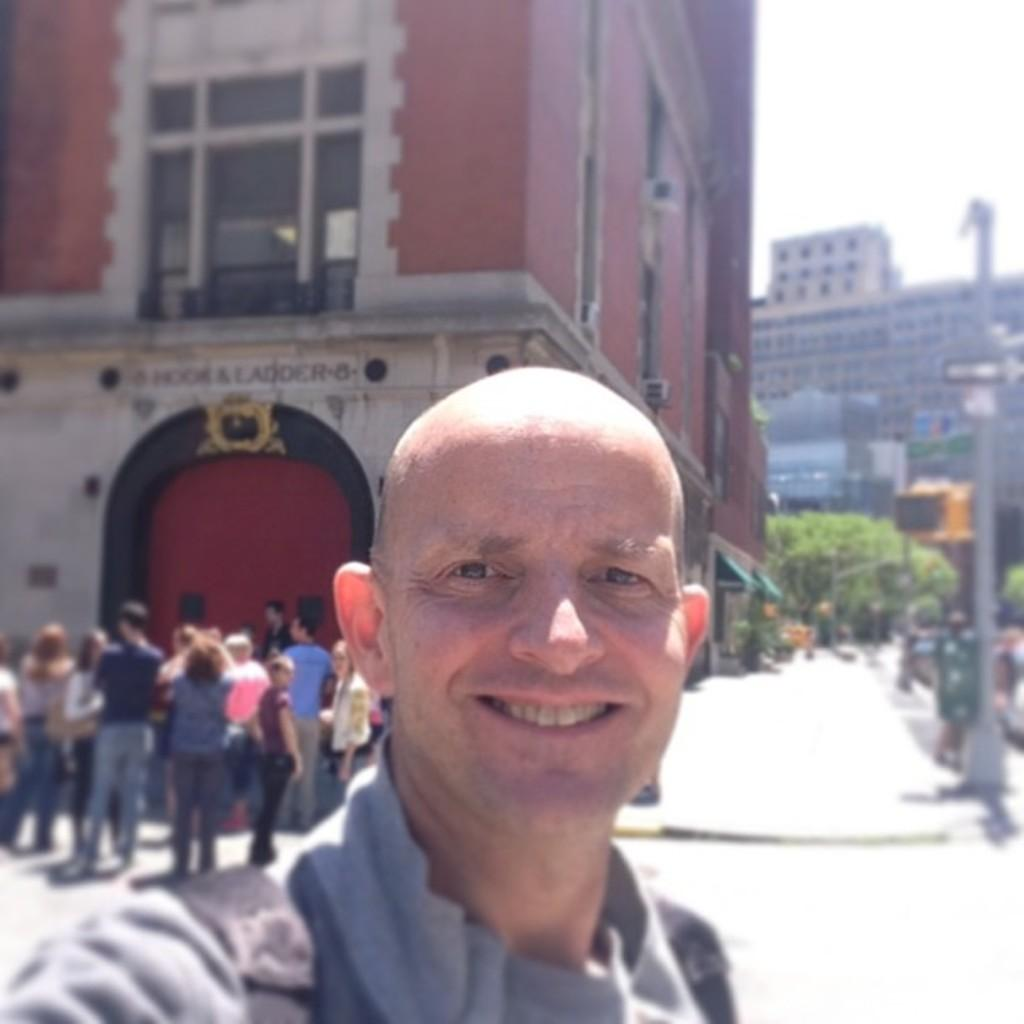Who is present in the image? There is a man in the image. What is the man doing in the image? The man is smiling in the image. What can be seen in the background of the image? There are buildings, trees, and poles in the background of the image. Are there any other people visible in the image? Yes, there are people visible in the image. What part of the natural environment is visible in the image? The sky is visible in the image. What type of knee injury is the man suffering from in the image? There is no indication of a knee injury in the image; the man is simply smiling. 